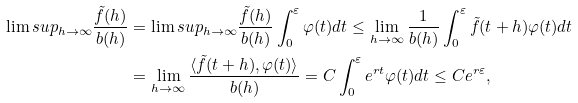Convert formula to latex. <formula><loc_0><loc_0><loc_500><loc_500>\lim s u p _ { h \to \infty } \frac { \tilde { f } ( h ) } { b ( h ) } & = \lim s u p _ { h \to \infty } \frac { \tilde { f } ( h ) } { b ( h ) } \int _ { 0 } ^ { \varepsilon } \varphi ( t ) d t \leq \lim _ { h \to \infty } \frac { 1 } { b ( h ) } \int _ { 0 } ^ { \varepsilon } \tilde { f } ( t + h ) \varphi ( t ) d t \\ & = \lim _ { h \to \infty } \frac { \langle \tilde { f } ( t + h ) , \varphi ( t ) \rangle } { b ( h ) } = C \int _ { 0 } ^ { \varepsilon } e ^ { r t } \varphi ( t ) d t \leq C e ^ { r \varepsilon } ,</formula> 